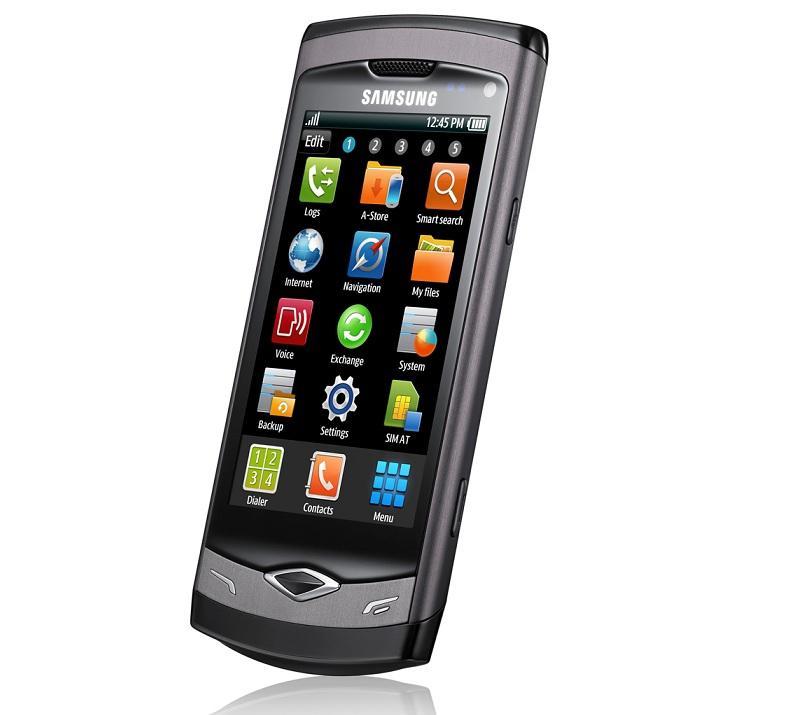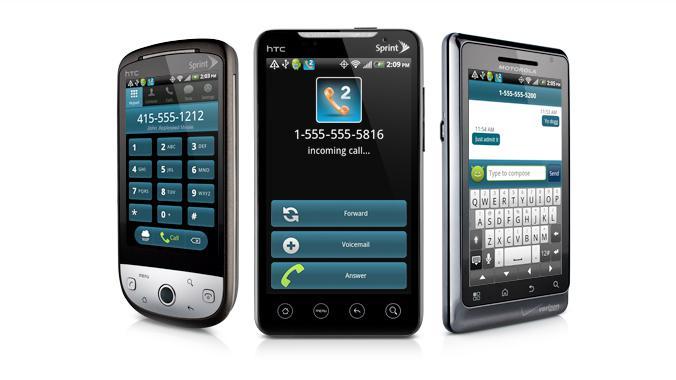The first image is the image on the left, the second image is the image on the right. For the images displayed, is the sentence "There are exactly two black phones in the right image." factually correct? Answer yes or no. No. The first image is the image on the left, the second image is the image on the right. Considering the images on both sides, is "One of the images shows a cell phone with app icons covering the screen and the other image shows three dark-colored cell phones." valid? Answer yes or no. Yes. 